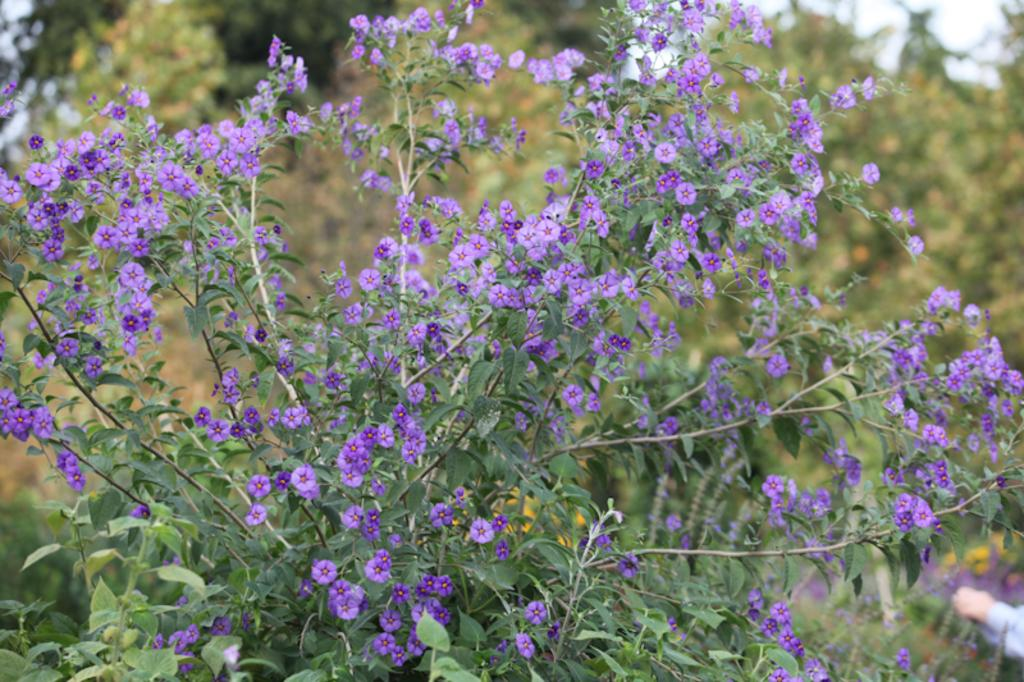What type of living organisms can be seen in the image? There are flowers in the image. Where are the flowers located? The flowers are on plants. What type of music is being played by the flowers in the image? There is no music being played by the flowers in the image, as flowers do not have the ability to play music. 